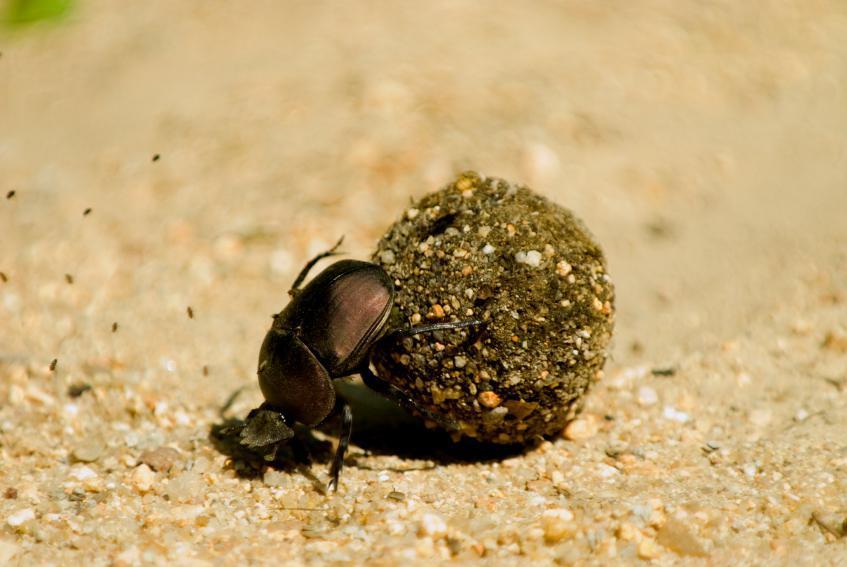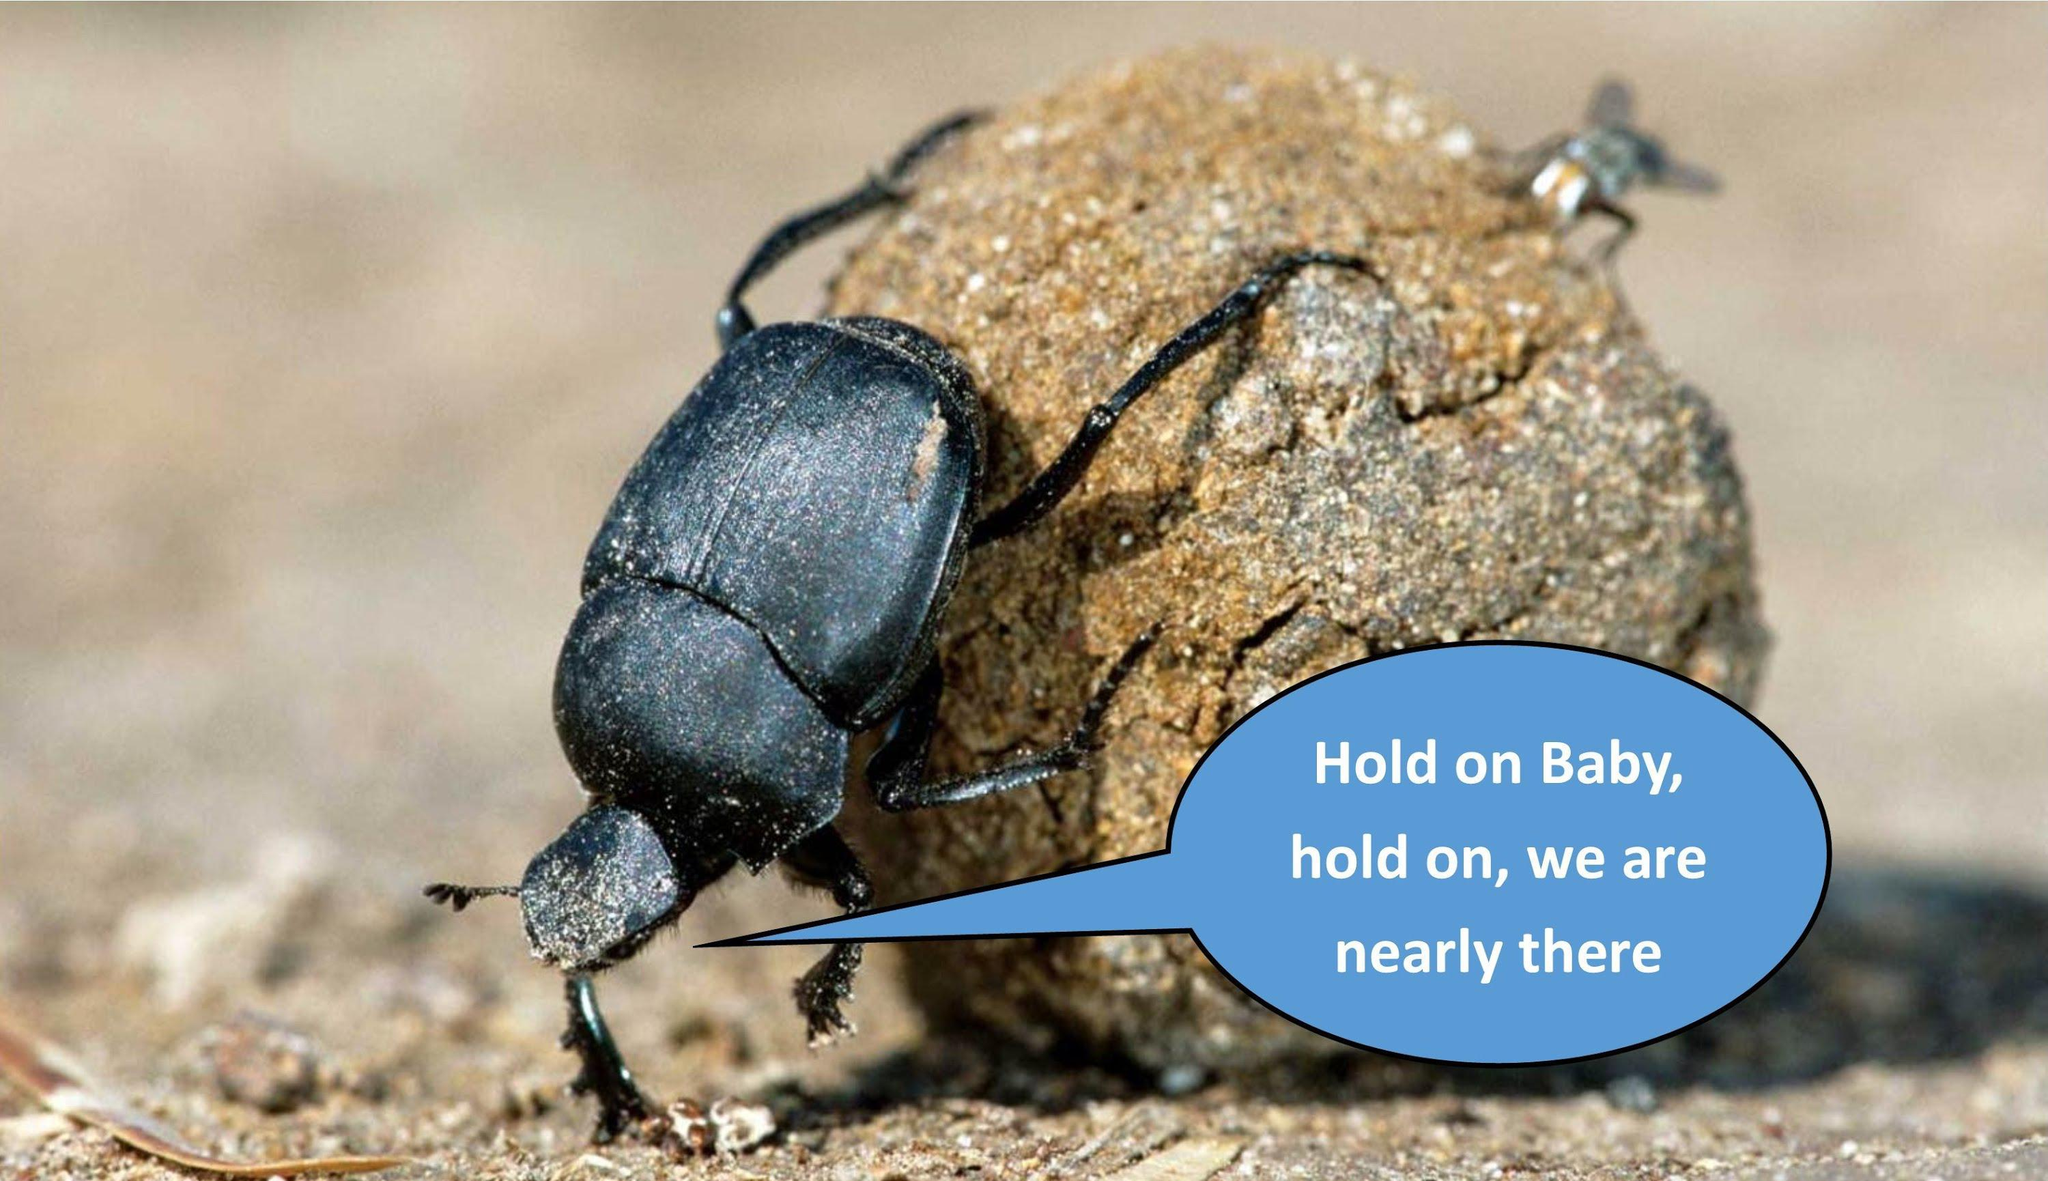The first image is the image on the left, the second image is the image on the right. Evaluate the accuracy of this statement regarding the images: "An image shows beetles on the left and right of one dungball, and each beetle is in contact with the ball.". Is it true? Answer yes or no. No. The first image is the image on the left, the second image is the image on the right. For the images shown, is this caption "There are only two beetles touching a dungball in the right image" true? Answer yes or no. No. 